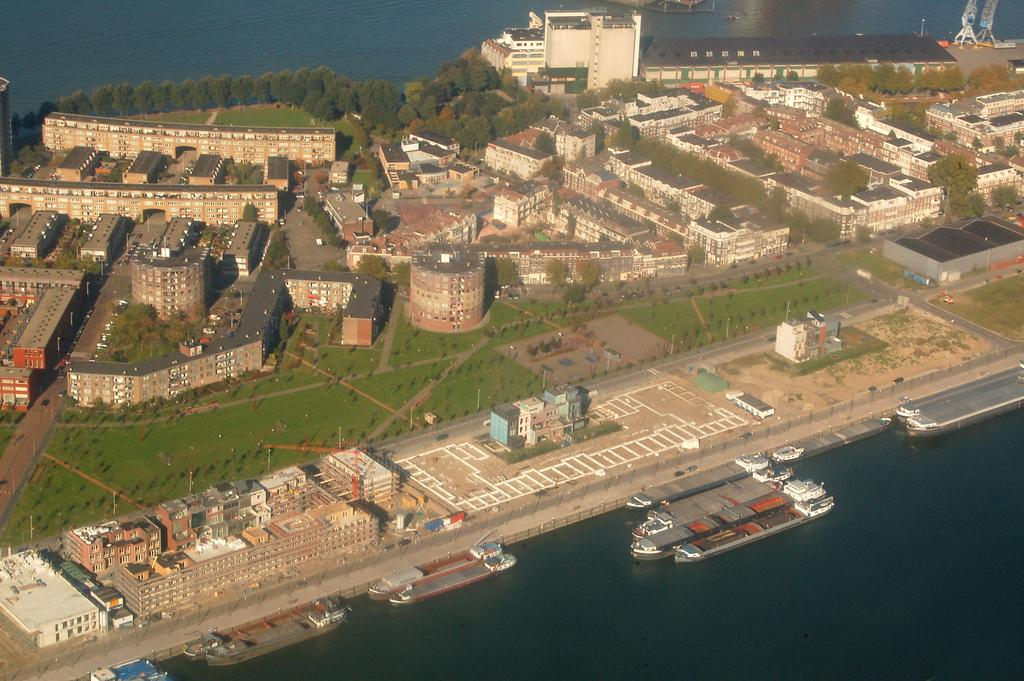What is at the bottom of the image? There is water at the bottom of the image. What can be seen floating in the water? There are ships in the water. What is located in the middle of the image? There are trees and buildings in the middle of the image. What is the nature of the image? The image appears to be a miniature representation. What type of sign can be seen in the image? There is no sign present in the image. What offer is being made by the trees in the image? The trees in the image are not making any offers; they are simply depicted as part of the landscape. 